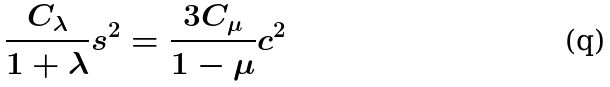Convert formula to latex. <formula><loc_0><loc_0><loc_500><loc_500>\frac { C _ { \lambda } } { 1 + \lambda } s ^ { 2 } = \frac { 3 C _ { \mu } } { 1 - \mu } c ^ { 2 } \,</formula> 